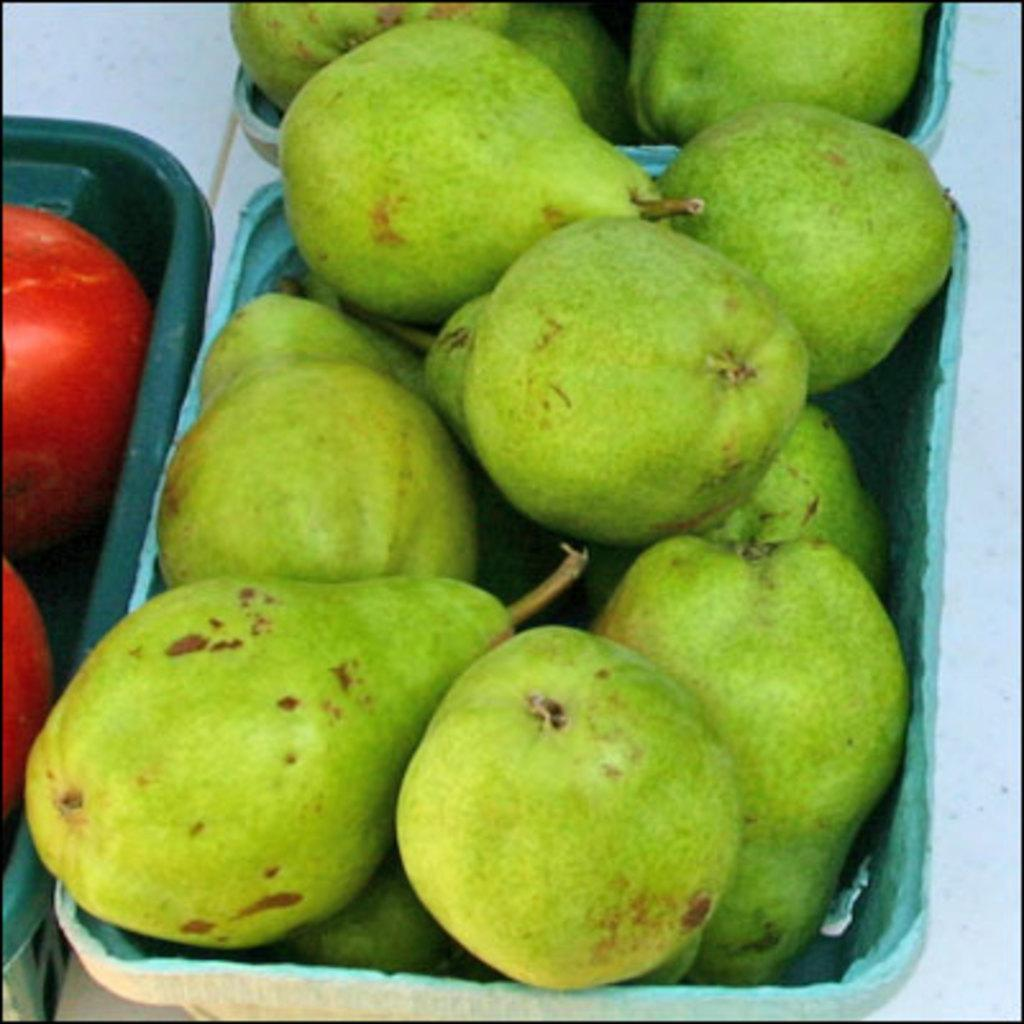What color are the boxes in the image? The boxes in the image are green. What is inside the green boxes? There are green color avocados in the boxes. What other color is present in the image besides green? There are red color things in the image. Can you see a monkey wearing a crown near the river in the image? There is no monkey, crown, or river present in the image. 